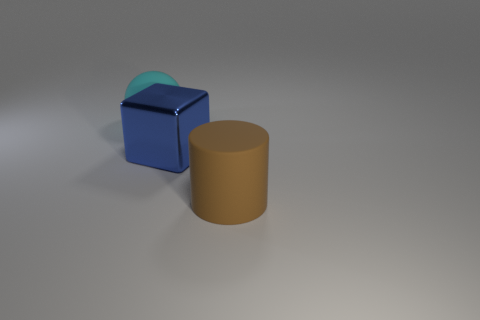What materials might the objects in the image be made of? The objects in the image could be made of a variety of materials. The matte appearance of the cylinder and cube suggest they could be made from a plastic or metal with a non-reflective finish, while the semi-transparent sphere on the cube looks like it could be made of glass or a clear plastic. 